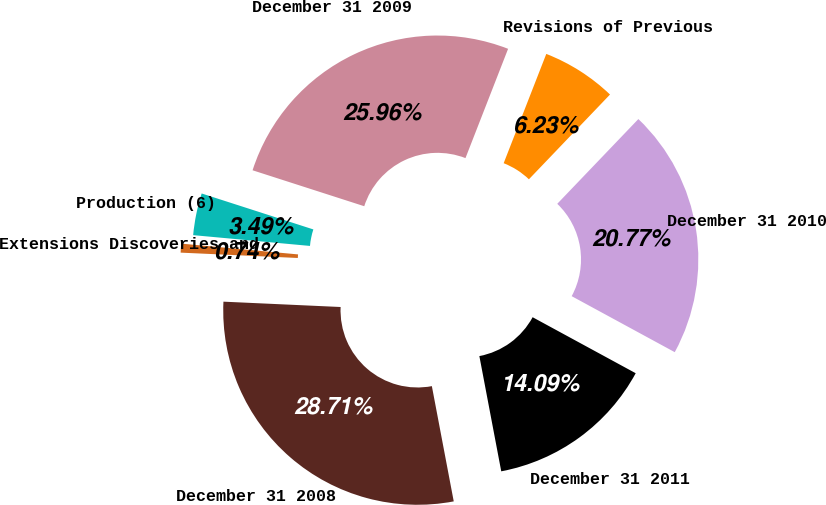Convert chart. <chart><loc_0><loc_0><loc_500><loc_500><pie_chart><fcel>December 31 2008<fcel>Extensions Discoveries and<fcel>Production (6)<fcel>December 31 2009<fcel>Revisions of Previous<fcel>December 31 2010<fcel>December 31 2011<nl><fcel>28.71%<fcel>0.74%<fcel>3.49%<fcel>25.96%<fcel>6.23%<fcel>20.77%<fcel>14.09%<nl></chart> 